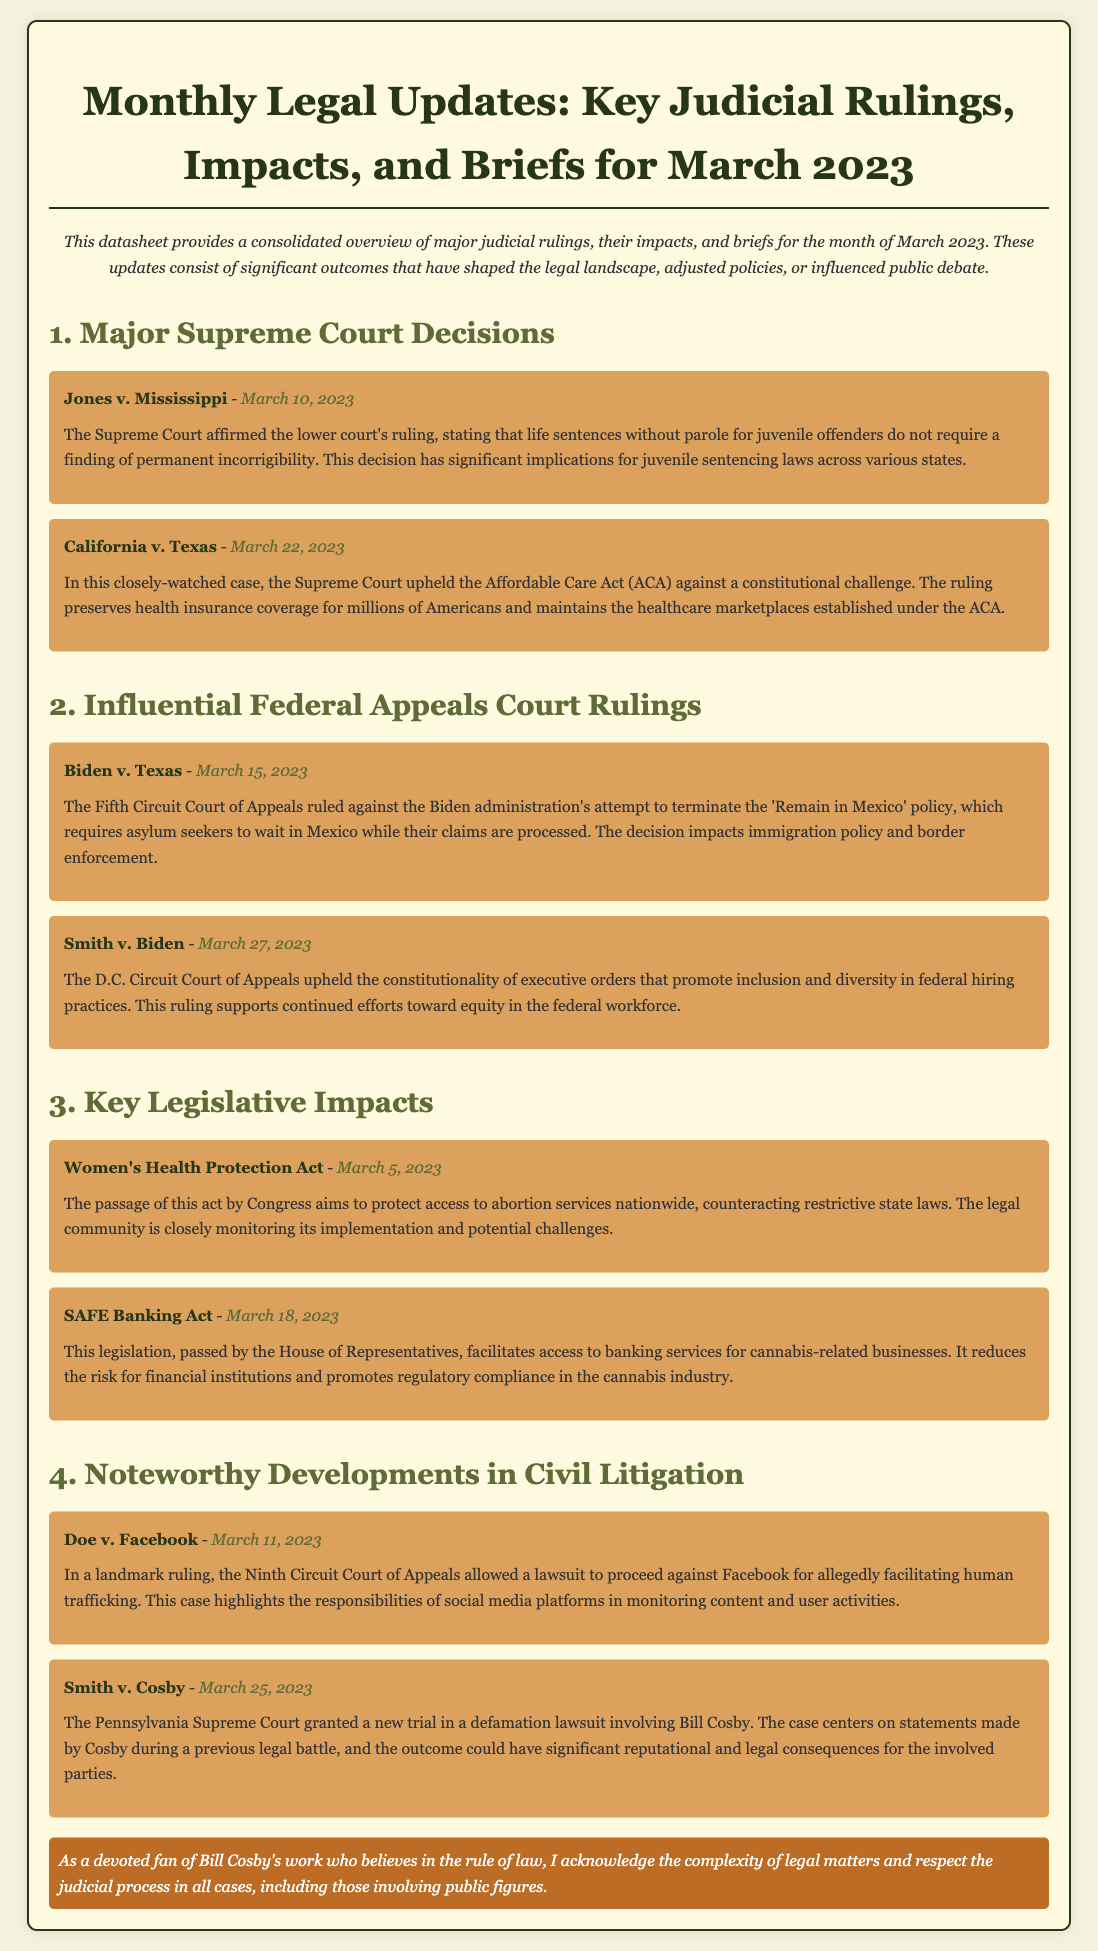What is the title of the document? The title of the document is provided at the beginning of the datasheet.
Answer: Monthly Legal Updates: Key Judicial Rulings, Impacts, and Briefs for March 2023 When was the case Jones v. Mississippi decided? The date of the decision is mentioned alongside the case name in the document.
Answer: March 10, 2023 What major act was passed on March 5, 2023? The document lists significant legislative acts along with their dates of passage.
Answer: Women's Health Protection Act Which case did the Pennsylvania Supreme Court grant a new trial for? The document specifies a notable case involving Bill Cosby in the section for civil litigation developments.
Answer: Smith v. Cosby What was upheld by the Supreme Court in California v. Texas? The document explains the outcome of this case in detail, focusing on the Affordable Care Act.
Answer: Affordable Care Act How did the Fifth Circuit rule in Biden v. Texas? The ruling's impact and the case's name are outlined within the section on federal appeals court rulings.
Answer: Against the Biden administration What is the significance of the SAFE Banking Act? The document provides a brief summary of legislative impacts and their implications for specific industries.
Answer: Facilitates banking for cannabis businesses What does the case Doe v. Facebook address? The document mentions the nature of this civil litigation case and its implications for social media platforms.
Answer: Human trafficking When was the SAFE Banking Act passed? The passage date is included in the summary of the legislative impacts.
Answer: March 18, 2023 